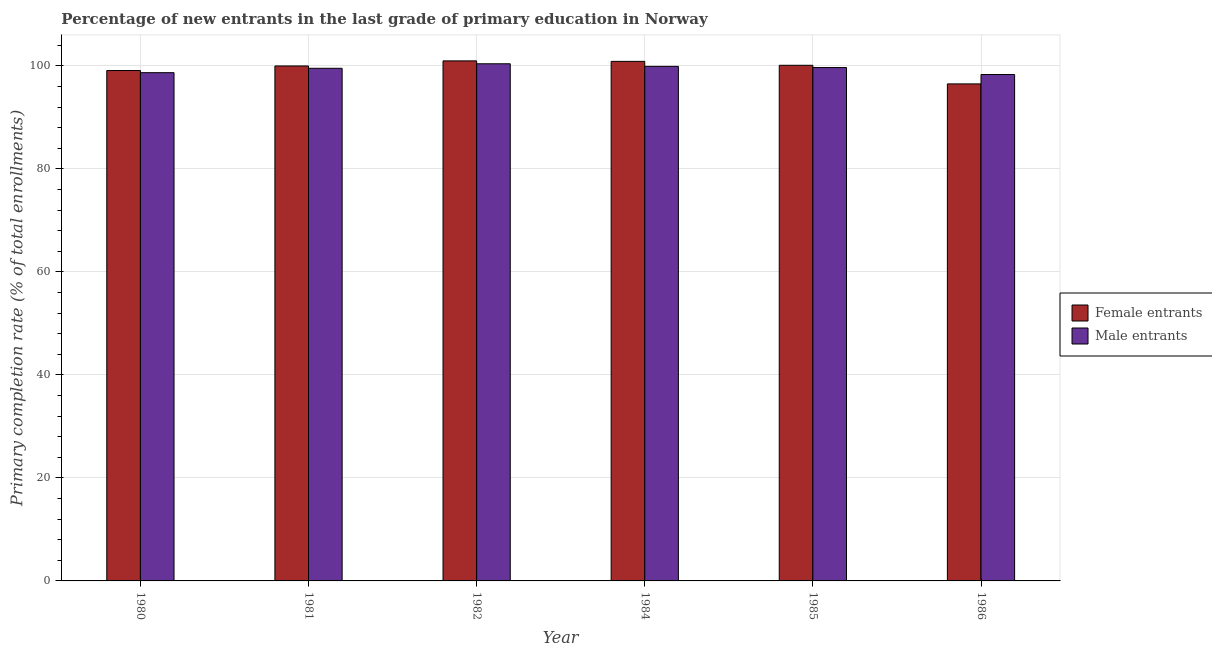How many groups of bars are there?
Ensure brevity in your answer.  6. Are the number of bars on each tick of the X-axis equal?
Provide a succinct answer. Yes. How many bars are there on the 5th tick from the right?
Your answer should be compact. 2. In how many cases, is the number of bars for a given year not equal to the number of legend labels?
Offer a very short reply. 0. What is the primary completion rate of female entrants in 1985?
Give a very brief answer. 100.1. Across all years, what is the maximum primary completion rate of female entrants?
Offer a very short reply. 100.96. Across all years, what is the minimum primary completion rate of female entrants?
Your answer should be compact. 96.49. In which year was the primary completion rate of male entrants maximum?
Your response must be concise. 1982. What is the total primary completion rate of male entrants in the graph?
Make the answer very short. 596.43. What is the difference between the primary completion rate of female entrants in 1980 and that in 1986?
Your response must be concise. 2.6. What is the difference between the primary completion rate of female entrants in 1984 and the primary completion rate of male entrants in 1986?
Keep it short and to the point. 4.38. What is the average primary completion rate of male entrants per year?
Your response must be concise. 99.4. What is the ratio of the primary completion rate of female entrants in 1980 to that in 1982?
Your response must be concise. 0.98. Is the difference between the primary completion rate of male entrants in 1980 and 1986 greater than the difference between the primary completion rate of female entrants in 1980 and 1986?
Your response must be concise. No. What is the difference between the highest and the second highest primary completion rate of male entrants?
Your answer should be very brief. 0.5. What is the difference between the highest and the lowest primary completion rate of female entrants?
Your answer should be very brief. 4.47. In how many years, is the primary completion rate of female entrants greater than the average primary completion rate of female entrants taken over all years?
Offer a terse response. 4. Is the sum of the primary completion rate of female entrants in 1982 and 1986 greater than the maximum primary completion rate of male entrants across all years?
Your answer should be very brief. Yes. What does the 2nd bar from the left in 1985 represents?
Your answer should be compact. Male entrants. What does the 2nd bar from the right in 1986 represents?
Provide a succinct answer. Female entrants. How many bars are there?
Offer a terse response. 12. Are all the bars in the graph horizontal?
Your response must be concise. No. How many years are there in the graph?
Offer a very short reply. 6. What is the difference between two consecutive major ticks on the Y-axis?
Offer a very short reply. 20. Are the values on the major ticks of Y-axis written in scientific E-notation?
Offer a terse response. No. Does the graph contain any zero values?
Make the answer very short. No. Does the graph contain grids?
Ensure brevity in your answer.  Yes. Where does the legend appear in the graph?
Make the answer very short. Center right. How many legend labels are there?
Make the answer very short. 2. How are the legend labels stacked?
Provide a succinct answer. Vertical. What is the title of the graph?
Provide a succinct answer. Percentage of new entrants in the last grade of primary education in Norway. Does "Private credit bureau" appear as one of the legend labels in the graph?
Provide a succinct answer. No. What is the label or title of the X-axis?
Provide a short and direct response. Year. What is the label or title of the Y-axis?
Ensure brevity in your answer.  Primary completion rate (% of total enrollments). What is the Primary completion rate (% of total enrollments) of Female entrants in 1980?
Keep it short and to the point. 99.08. What is the Primary completion rate (% of total enrollments) of Male entrants in 1980?
Give a very brief answer. 98.66. What is the Primary completion rate (% of total enrollments) of Female entrants in 1981?
Your answer should be compact. 99.97. What is the Primary completion rate (% of total enrollments) in Male entrants in 1981?
Your answer should be very brief. 99.52. What is the Primary completion rate (% of total enrollments) in Female entrants in 1982?
Keep it short and to the point. 100.96. What is the Primary completion rate (% of total enrollments) in Male entrants in 1982?
Your response must be concise. 100.39. What is the Primary completion rate (% of total enrollments) in Female entrants in 1984?
Your answer should be compact. 100.86. What is the Primary completion rate (% of total enrollments) of Male entrants in 1984?
Your answer should be very brief. 99.89. What is the Primary completion rate (% of total enrollments) of Female entrants in 1985?
Provide a short and direct response. 100.1. What is the Primary completion rate (% of total enrollments) in Male entrants in 1985?
Make the answer very short. 99.66. What is the Primary completion rate (% of total enrollments) in Female entrants in 1986?
Offer a terse response. 96.49. What is the Primary completion rate (% of total enrollments) of Male entrants in 1986?
Your response must be concise. 98.31. Across all years, what is the maximum Primary completion rate (% of total enrollments) of Female entrants?
Your answer should be very brief. 100.96. Across all years, what is the maximum Primary completion rate (% of total enrollments) of Male entrants?
Provide a short and direct response. 100.39. Across all years, what is the minimum Primary completion rate (% of total enrollments) in Female entrants?
Give a very brief answer. 96.49. Across all years, what is the minimum Primary completion rate (% of total enrollments) in Male entrants?
Your answer should be compact. 98.31. What is the total Primary completion rate (% of total enrollments) of Female entrants in the graph?
Give a very brief answer. 597.45. What is the total Primary completion rate (% of total enrollments) of Male entrants in the graph?
Your response must be concise. 596.43. What is the difference between the Primary completion rate (% of total enrollments) in Female entrants in 1980 and that in 1981?
Provide a succinct answer. -0.89. What is the difference between the Primary completion rate (% of total enrollments) in Male entrants in 1980 and that in 1981?
Provide a short and direct response. -0.85. What is the difference between the Primary completion rate (% of total enrollments) of Female entrants in 1980 and that in 1982?
Keep it short and to the point. -1.87. What is the difference between the Primary completion rate (% of total enrollments) in Male entrants in 1980 and that in 1982?
Ensure brevity in your answer.  -1.73. What is the difference between the Primary completion rate (% of total enrollments) of Female entrants in 1980 and that in 1984?
Provide a short and direct response. -1.78. What is the difference between the Primary completion rate (% of total enrollments) in Male entrants in 1980 and that in 1984?
Ensure brevity in your answer.  -1.23. What is the difference between the Primary completion rate (% of total enrollments) of Female entrants in 1980 and that in 1985?
Ensure brevity in your answer.  -1.02. What is the difference between the Primary completion rate (% of total enrollments) in Male entrants in 1980 and that in 1985?
Make the answer very short. -0.99. What is the difference between the Primary completion rate (% of total enrollments) of Female entrants in 1980 and that in 1986?
Your answer should be very brief. 2.6. What is the difference between the Primary completion rate (% of total enrollments) of Male entrants in 1980 and that in 1986?
Your answer should be compact. 0.35. What is the difference between the Primary completion rate (% of total enrollments) in Female entrants in 1981 and that in 1982?
Offer a very short reply. -0.99. What is the difference between the Primary completion rate (% of total enrollments) in Male entrants in 1981 and that in 1982?
Offer a terse response. -0.87. What is the difference between the Primary completion rate (% of total enrollments) of Female entrants in 1981 and that in 1984?
Offer a terse response. -0.89. What is the difference between the Primary completion rate (% of total enrollments) in Male entrants in 1981 and that in 1984?
Give a very brief answer. -0.37. What is the difference between the Primary completion rate (% of total enrollments) in Female entrants in 1981 and that in 1985?
Your answer should be very brief. -0.13. What is the difference between the Primary completion rate (% of total enrollments) in Male entrants in 1981 and that in 1985?
Offer a very short reply. -0.14. What is the difference between the Primary completion rate (% of total enrollments) of Female entrants in 1981 and that in 1986?
Give a very brief answer. 3.48. What is the difference between the Primary completion rate (% of total enrollments) of Male entrants in 1981 and that in 1986?
Your answer should be compact. 1.21. What is the difference between the Primary completion rate (% of total enrollments) in Female entrants in 1982 and that in 1984?
Make the answer very short. 0.09. What is the difference between the Primary completion rate (% of total enrollments) of Male entrants in 1982 and that in 1984?
Ensure brevity in your answer.  0.5. What is the difference between the Primary completion rate (% of total enrollments) of Female entrants in 1982 and that in 1985?
Provide a succinct answer. 0.86. What is the difference between the Primary completion rate (% of total enrollments) of Male entrants in 1982 and that in 1985?
Offer a very short reply. 0.73. What is the difference between the Primary completion rate (% of total enrollments) of Female entrants in 1982 and that in 1986?
Your response must be concise. 4.47. What is the difference between the Primary completion rate (% of total enrollments) in Male entrants in 1982 and that in 1986?
Your answer should be very brief. 2.08. What is the difference between the Primary completion rate (% of total enrollments) in Female entrants in 1984 and that in 1985?
Your response must be concise. 0.76. What is the difference between the Primary completion rate (% of total enrollments) of Male entrants in 1984 and that in 1985?
Make the answer very short. 0.23. What is the difference between the Primary completion rate (% of total enrollments) in Female entrants in 1984 and that in 1986?
Offer a terse response. 4.38. What is the difference between the Primary completion rate (% of total enrollments) of Male entrants in 1984 and that in 1986?
Make the answer very short. 1.58. What is the difference between the Primary completion rate (% of total enrollments) of Female entrants in 1985 and that in 1986?
Your answer should be very brief. 3.61. What is the difference between the Primary completion rate (% of total enrollments) in Male entrants in 1985 and that in 1986?
Provide a succinct answer. 1.35. What is the difference between the Primary completion rate (% of total enrollments) of Female entrants in 1980 and the Primary completion rate (% of total enrollments) of Male entrants in 1981?
Offer a terse response. -0.43. What is the difference between the Primary completion rate (% of total enrollments) in Female entrants in 1980 and the Primary completion rate (% of total enrollments) in Male entrants in 1982?
Your answer should be very brief. -1.31. What is the difference between the Primary completion rate (% of total enrollments) in Female entrants in 1980 and the Primary completion rate (% of total enrollments) in Male entrants in 1984?
Offer a terse response. -0.81. What is the difference between the Primary completion rate (% of total enrollments) of Female entrants in 1980 and the Primary completion rate (% of total enrollments) of Male entrants in 1985?
Your answer should be very brief. -0.57. What is the difference between the Primary completion rate (% of total enrollments) of Female entrants in 1980 and the Primary completion rate (% of total enrollments) of Male entrants in 1986?
Provide a succinct answer. 0.77. What is the difference between the Primary completion rate (% of total enrollments) in Female entrants in 1981 and the Primary completion rate (% of total enrollments) in Male entrants in 1982?
Your response must be concise. -0.42. What is the difference between the Primary completion rate (% of total enrollments) in Female entrants in 1981 and the Primary completion rate (% of total enrollments) in Male entrants in 1984?
Your answer should be compact. 0.08. What is the difference between the Primary completion rate (% of total enrollments) in Female entrants in 1981 and the Primary completion rate (% of total enrollments) in Male entrants in 1985?
Ensure brevity in your answer.  0.31. What is the difference between the Primary completion rate (% of total enrollments) in Female entrants in 1981 and the Primary completion rate (% of total enrollments) in Male entrants in 1986?
Provide a succinct answer. 1.66. What is the difference between the Primary completion rate (% of total enrollments) of Female entrants in 1982 and the Primary completion rate (% of total enrollments) of Male entrants in 1984?
Your response must be concise. 1.07. What is the difference between the Primary completion rate (% of total enrollments) in Female entrants in 1982 and the Primary completion rate (% of total enrollments) in Male entrants in 1985?
Keep it short and to the point. 1.3. What is the difference between the Primary completion rate (% of total enrollments) of Female entrants in 1982 and the Primary completion rate (% of total enrollments) of Male entrants in 1986?
Offer a very short reply. 2.64. What is the difference between the Primary completion rate (% of total enrollments) in Female entrants in 1984 and the Primary completion rate (% of total enrollments) in Male entrants in 1985?
Ensure brevity in your answer.  1.2. What is the difference between the Primary completion rate (% of total enrollments) in Female entrants in 1984 and the Primary completion rate (% of total enrollments) in Male entrants in 1986?
Make the answer very short. 2.55. What is the difference between the Primary completion rate (% of total enrollments) in Female entrants in 1985 and the Primary completion rate (% of total enrollments) in Male entrants in 1986?
Make the answer very short. 1.79. What is the average Primary completion rate (% of total enrollments) of Female entrants per year?
Keep it short and to the point. 99.58. What is the average Primary completion rate (% of total enrollments) in Male entrants per year?
Offer a terse response. 99.4. In the year 1980, what is the difference between the Primary completion rate (% of total enrollments) of Female entrants and Primary completion rate (% of total enrollments) of Male entrants?
Your response must be concise. 0.42. In the year 1981, what is the difference between the Primary completion rate (% of total enrollments) of Female entrants and Primary completion rate (% of total enrollments) of Male entrants?
Provide a succinct answer. 0.45. In the year 1982, what is the difference between the Primary completion rate (% of total enrollments) in Female entrants and Primary completion rate (% of total enrollments) in Male entrants?
Give a very brief answer. 0.56. In the year 1984, what is the difference between the Primary completion rate (% of total enrollments) of Female entrants and Primary completion rate (% of total enrollments) of Male entrants?
Ensure brevity in your answer.  0.97. In the year 1985, what is the difference between the Primary completion rate (% of total enrollments) of Female entrants and Primary completion rate (% of total enrollments) of Male entrants?
Ensure brevity in your answer.  0.44. In the year 1986, what is the difference between the Primary completion rate (% of total enrollments) of Female entrants and Primary completion rate (% of total enrollments) of Male entrants?
Give a very brief answer. -1.82. What is the ratio of the Primary completion rate (% of total enrollments) in Female entrants in 1980 to that in 1981?
Your answer should be very brief. 0.99. What is the ratio of the Primary completion rate (% of total enrollments) in Female entrants in 1980 to that in 1982?
Your answer should be compact. 0.98. What is the ratio of the Primary completion rate (% of total enrollments) in Male entrants in 1980 to that in 1982?
Offer a very short reply. 0.98. What is the ratio of the Primary completion rate (% of total enrollments) of Female entrants in 1980 to that in 1984?
Your answer should be compact. 0.98. What is the ratio of the Primary completion rate (% of total enrollments) in Female entrants in 1980 to that in 1985?
Offer a very short reply. 0.99. What is the ratio of the Primary completion rate (% of total enrollments) of Male entrants in 1980 to that in 1985?
Give a very brief answer. 0.99. What is the ratio of the Primary completion rate (% of total enrollments) of Female entrants in 1980 to that in 1986?
Keep it short and to the point. 1.03. What is the ratio of the Primary completion rate (% of total enrollments) of Female entrants in 1981 to that in 1982?
Your response must be concise. 0.99. What is the ratio of the Primary completion rate (% of total enrollments) in Male entrants in 1981 to that in 1982?
Your answer should be very brief. 0.99. What is the ratio of the Primary completion rate (% of total enrollments) in Female entrants in 1981 to that in 1984?
Keep it short and to the point. 0.99. What is the ratio of the Primary completion rate (% of total enrollments) of Male entrants in 1981 to that in 1984?
Make the answer very short. 1. What is the ratio of the Primary completion rate (% of total enrollments) of Female entrants in 1981 to that in 1986?
Offer a terse response. 1.04. What is the ratio of the Primary completion rate (% of total enrollments) of Male entrants in 1981 to that in 1986?
Your response must be concise. 1.01. What is the ratio of the Primary completion rate (% of total enrollments) in Male entrants in 1982 to that in 1984?
Offer a very short reply. 1. What is the ratio of the Primary completion rate (% of total enrollments) of Female entrants in 1982 to that in 1985?
Your answer should be very brief. 1.01. What is the ratio of the Primary completion rate (% of total enrollments) in Male entrants in 1982 to that in 1985?
Your response must be concise. 1.01. What is the ratio of the Primary completion rate (% of total enrollments) of Female entrants in 1982 to that in 1986?
Make the answer very short. 1.05. What is the ratio of the Primary completion rate (% of total enrollments) of Male entrants in 1982 to that in 1986?
Your answer should be very brief. 1.02. What is the ratio of the Primary completion rate (% of total enrollments) in Female entrants in 1984 to that in 1985?
Give a very brief answer. 1.01. What is the ratio of the Primary completion rate (% of total enrollments) in Female entrants in 1984 to that in 1986?
Give a very brief answer. 1.05. What is the ratio of the Primary completion rate (% of total enrollments) of Male entrants in 1984 to that in 1986?
Offer a terse response. 1.02. What is the ratio of the Primary completion rate (% of total enrollments) in Female entrants in 1985 to that in 1986?
Provide a short and direct response. 1.04. What is the ratio of the Primary completion rate (% of total enrollments) in Male entrants in 1985 to that in 1986?
Offer a terse response. 1.01. What is the difference between the highest and the second highest Primary completion rate (% of total enrollments) in Female entrants?
Make the answer very short. 0.09. What is the difference between the highest and the second highest Primary completion rate (% of total enrollments) in Male entrants?
Provide a short and direct response. 0.5. What is the difference between the highest and the lowest Primary completion rate (% of total enrollments) of Female entrants?
Make the answer very short. 4.47. What is the difference between the highest and the lowest Primary completion rate (% of total enrollments) in Male entrants?
Make the answer very short. 2.08. 